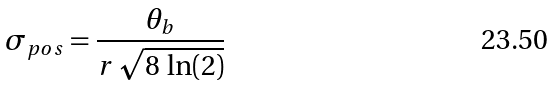<formula> <loc_0><loc_0><loc_500><loc_500>\sigma _ { p o s } = \frac { \theta _ { b } } { r \, \sqrt { 8 \, \ln ( 2 ) } }</formula> 